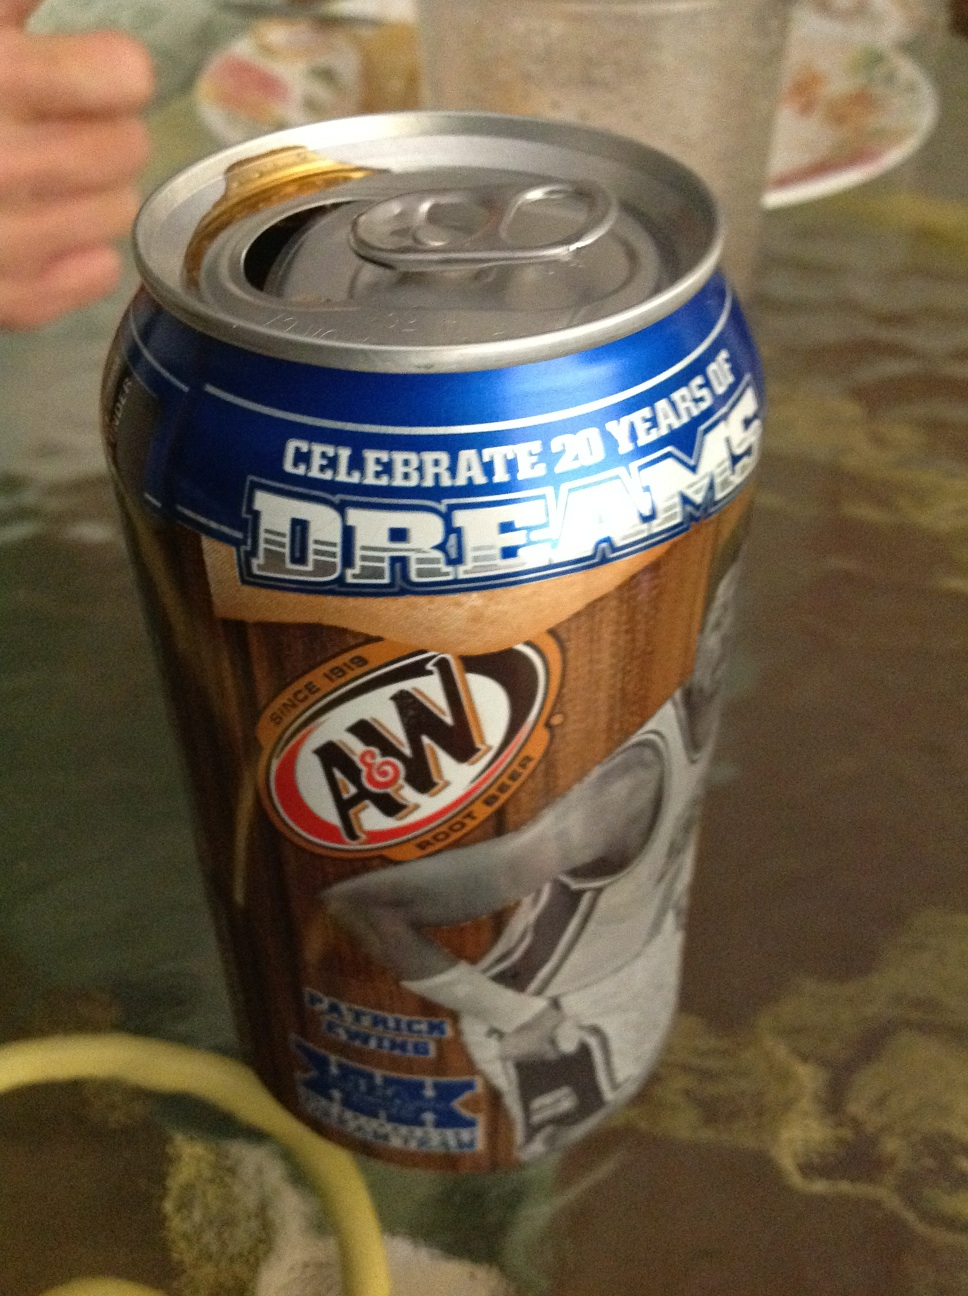Imagine if this can was found 100 years in the future. Describe the potential historical significance it could hold. If this can was found 100 years in the future, it could be a fascinating artifact representing early 21st-century marketing and sports culture. The special edition design would likely highlight the importance of sports figures in branding and how companies like A&W celebrated milestones. The imagery could provide insights into the popular sports and celebrities of the time, while the can itself might be an example of packaging design from that era. 